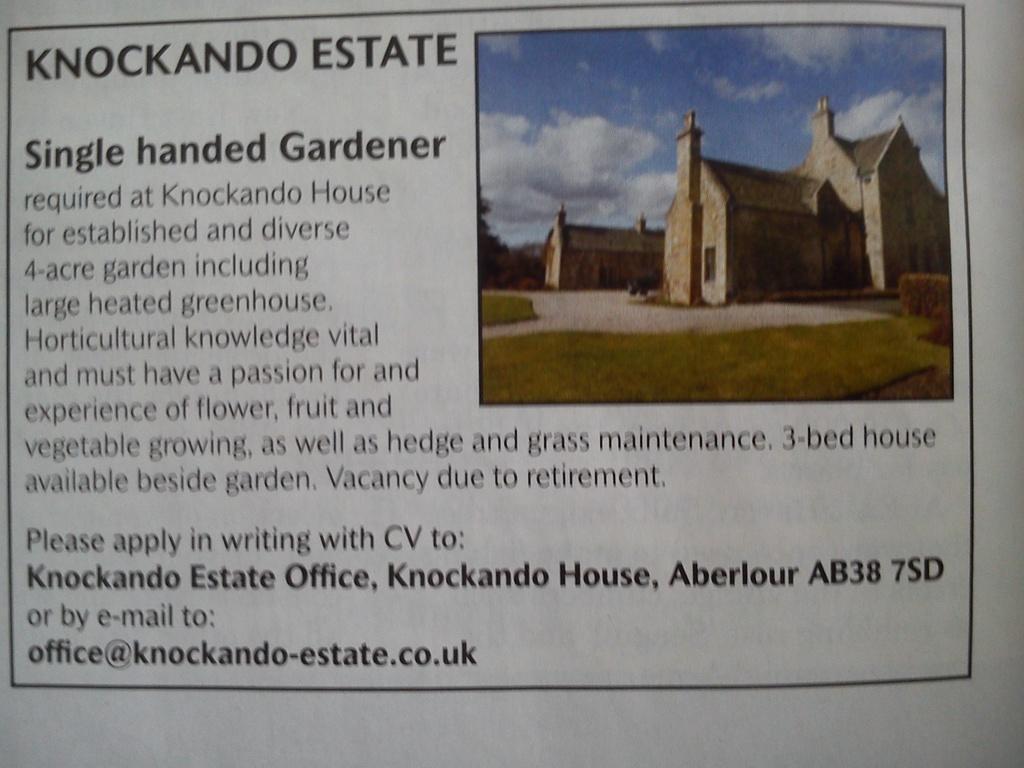How would you summarize this image in a sentence or two? In this image I can see few buildings in brown and cream color, trees in green color and the sky is in blue and white color and I can see something written on the image. 